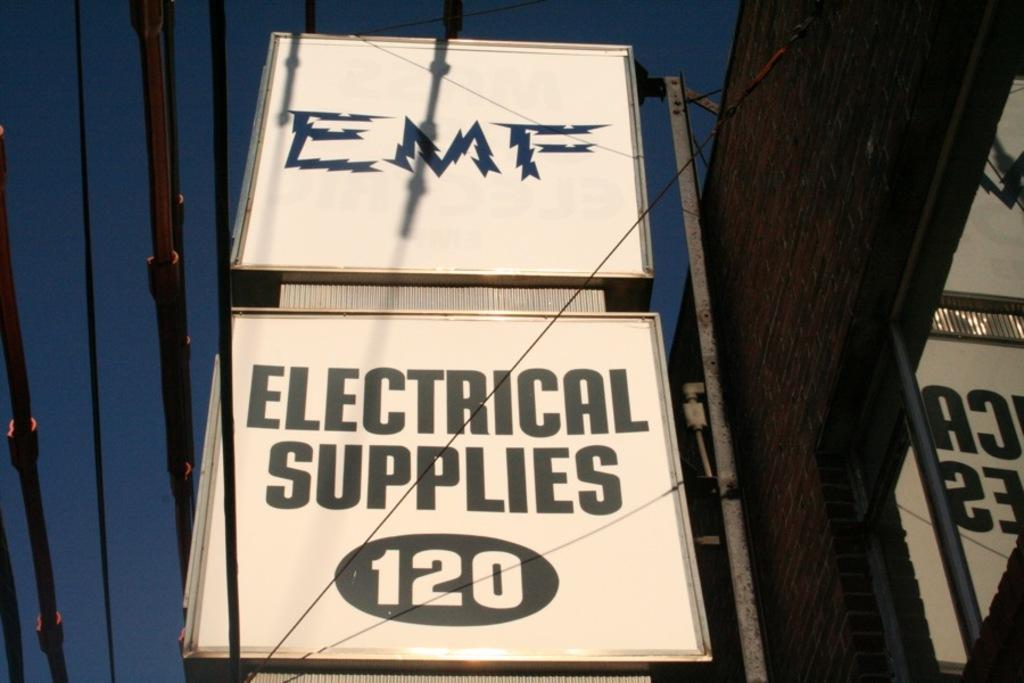<image>
Provide a brief description of the given image. a sign that reads EMF Electical supplies 120 